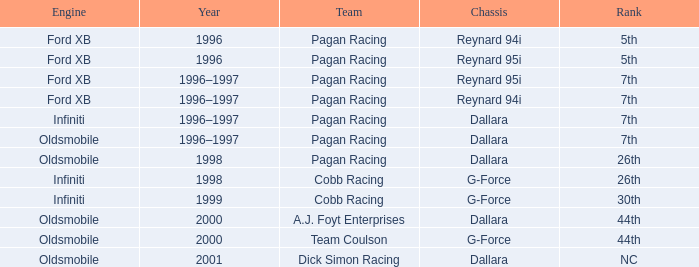In 2000, what position did the dallara chassis achieve? 44th. 